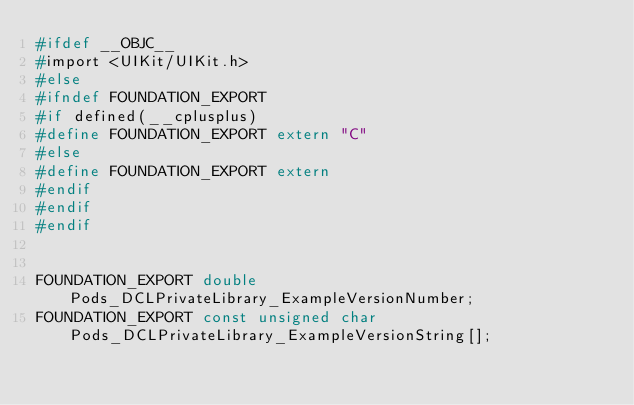<code> <loc_0><loc_0><loc_500><loc_500><_C_>#ifdef __OBJC__
#import <UIKit/UIKit.h>
#else
#ifndef FOUNDATION_EXPORT
#if defined(__cplusplus)
#define FOUNDATION_EXPORT extern "C"
#else
#define FOUNDATION_EXPORT extern
#endif
#endif
#endif


FOUNDATION_EXPORT double Pods_DCLPrivateLibrary_ExampleVersionNumber;
FOUNDATION_EXPORT const unsigned char Pods_DCLPrivateLibrary_ExampleVersionString[];

</code> 